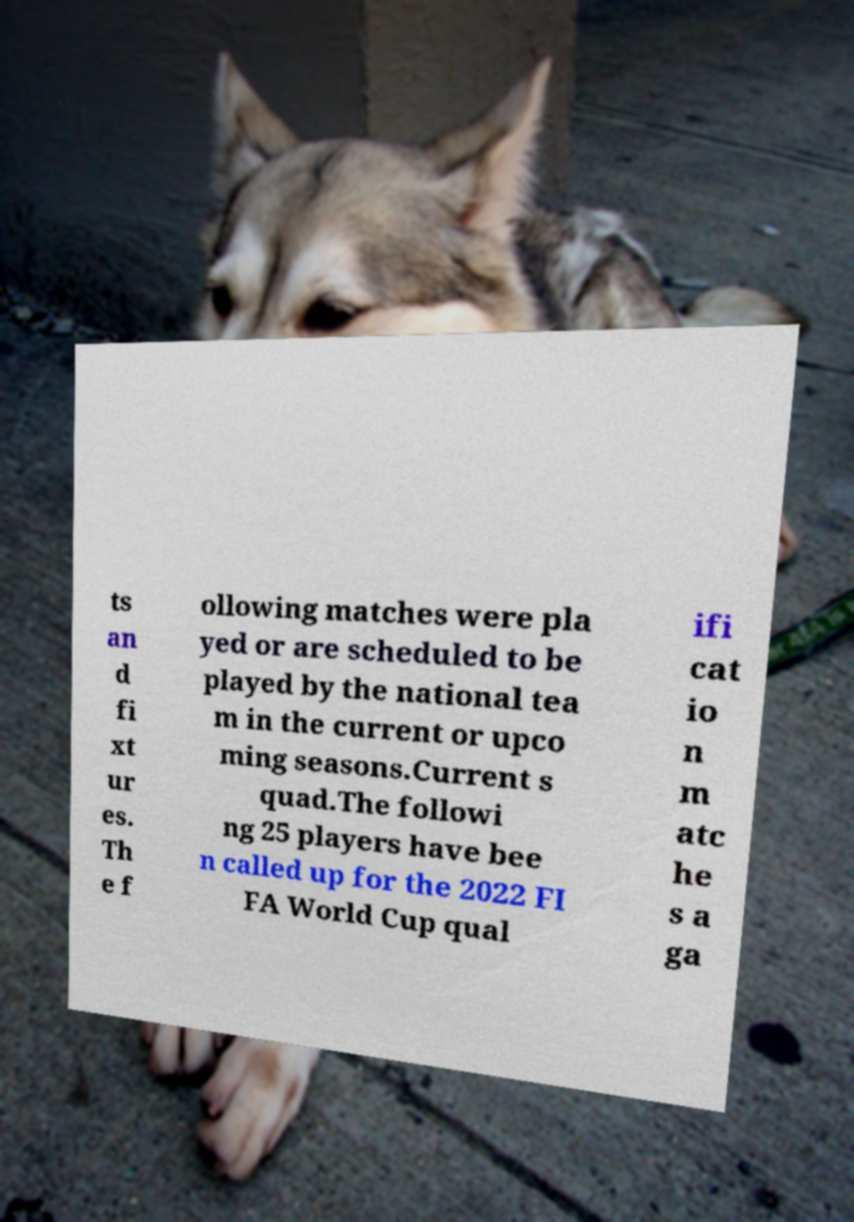Please identify and transcribe the text found in this image. ts an d fi xt ur es. Th e f ollowing matches were pla yed or are scheduled to be played by the national tea m in the current or upco ming seasons.Current s quad.The followi ng 25 players have bee n called up for the 2022 FI FA World Cup qual ifi cat io n m atc he s a ga 